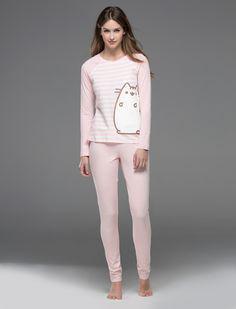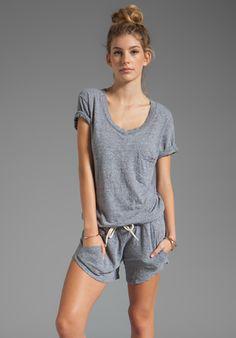The first image is the image on the left, the second image is the image on the right. Given the left and right images, does the statement "Of two pajama sets, one is pink with long sleeves and pants, while the other is a matching set of top with short pants." hold true? Answer yes or no. Yes. The first image is the image on the left, the second image is the image on the right. Evaluate the accuracy of this statement regarding the images: "One woman wears shorts while the other wears pants.". Is it true? Answer yes or no. Yes. 